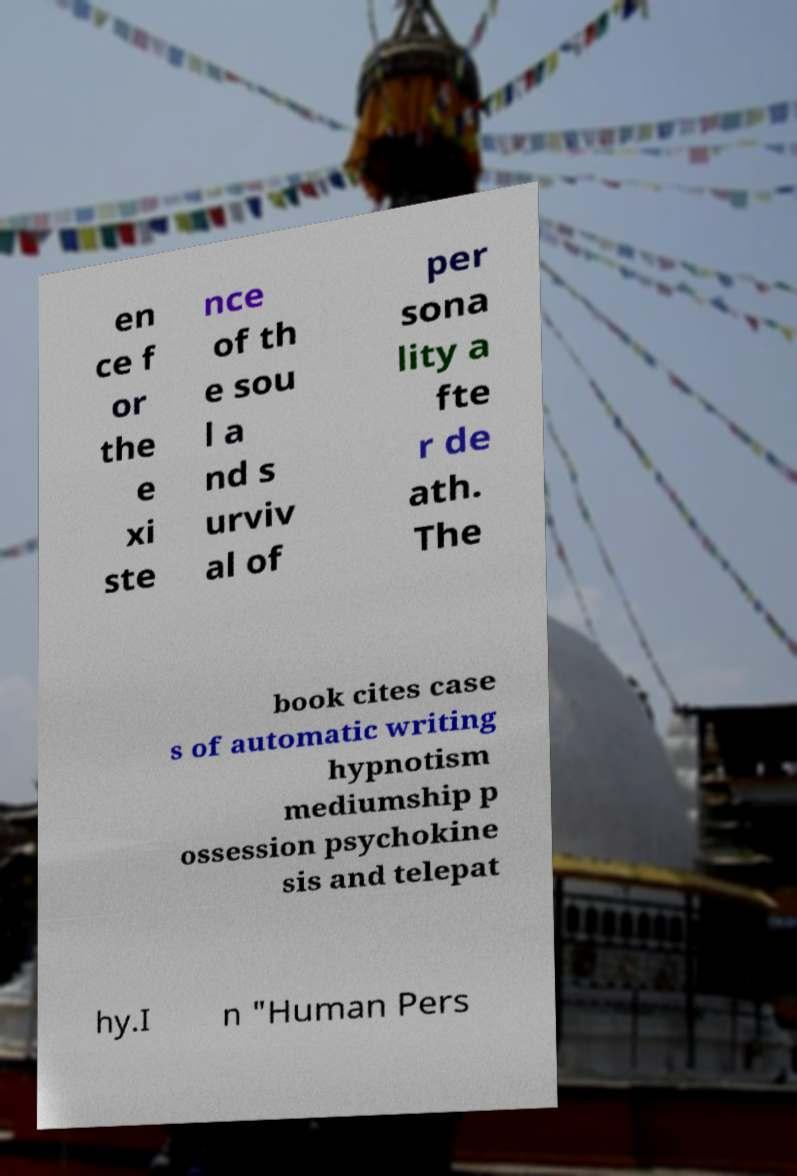Please identify and transcribe the text found in this image. en ce f or the e xi ste nce of th e sou l a nd s urviv al of per sona lity a fte r de ath. The book cites case s of automatic writing hypnotism mediumship p ossession psychokine sis and telepat hy.I n "Human Pers 